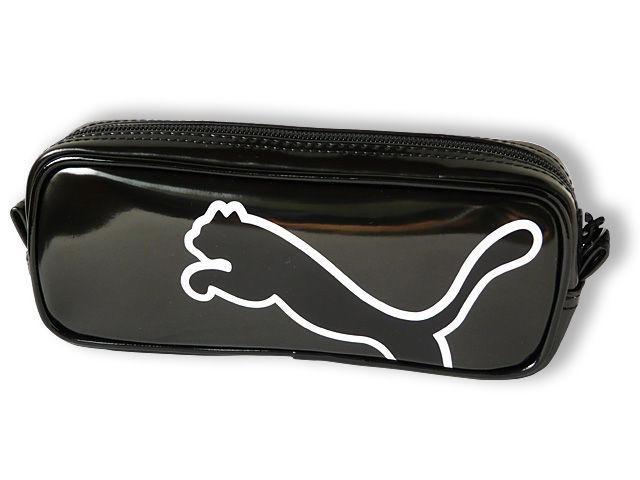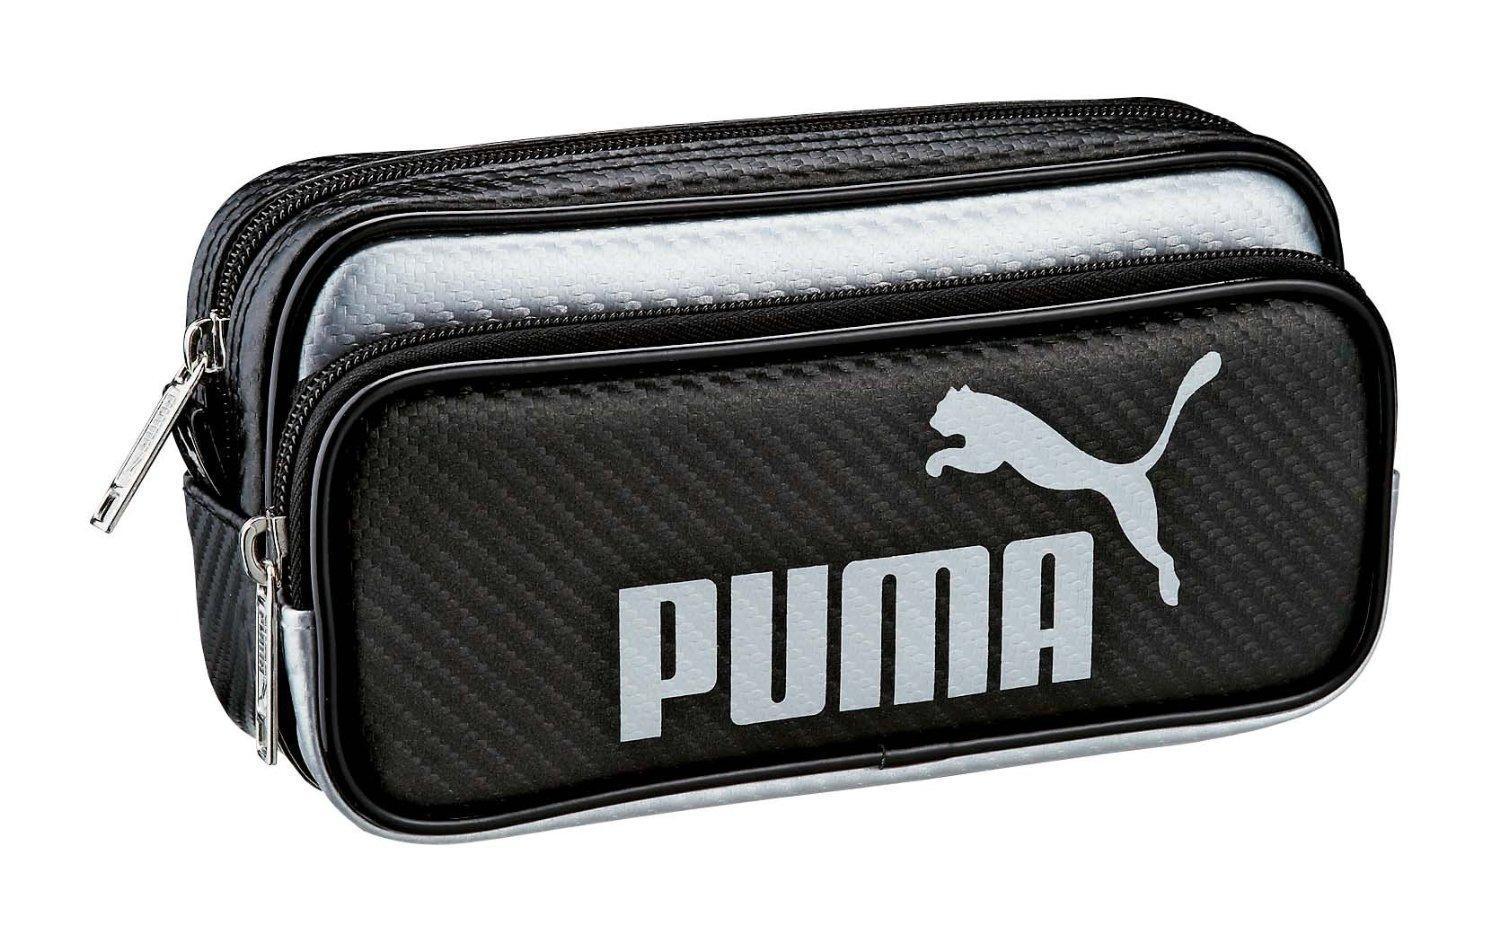The first image is the image on the left, the second image is the image on the right. Examine the images to the left and right. Is the description "Exactly one bag has the company name and the company logo on it." accurate? Answer yes or no. Yes. The first image is the image on the left, the second image is the image on the right. For the images displayed, is the sentence "Each image contains one pencil case with a wildcat silhouette on it, and the right image features a case with a curving line that separates its colors." factually correct? Answer yes or no. No. 